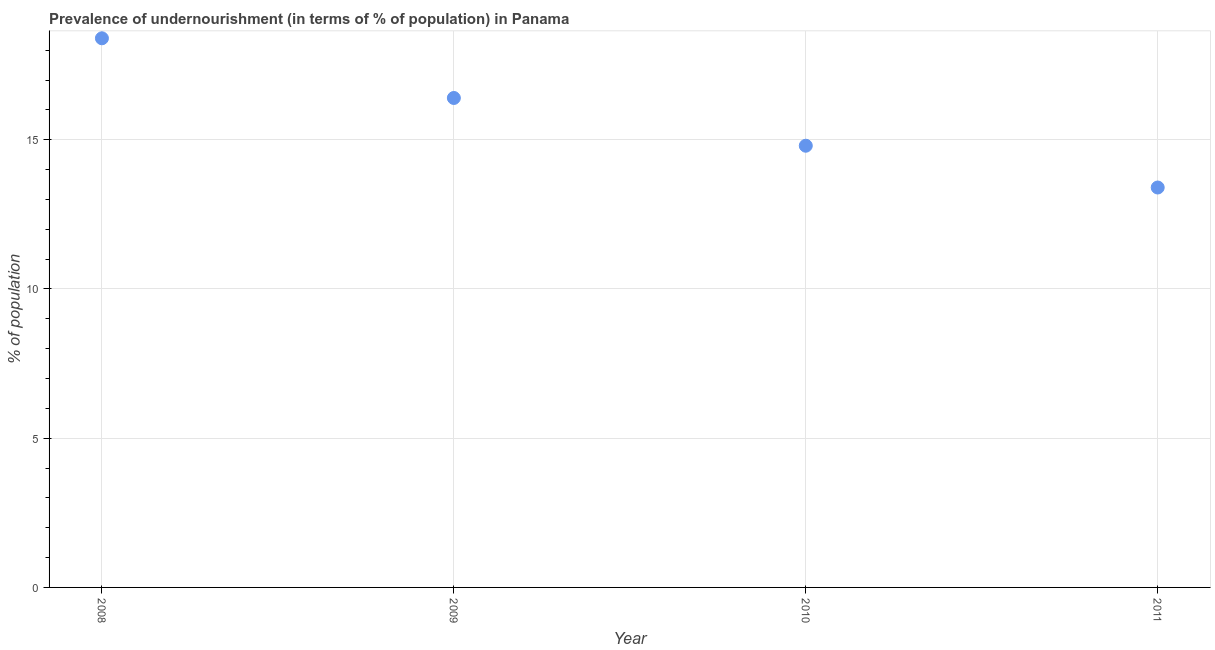What is the percentage of undernourished population in 2008?
Give a very brief answer. 18.4. Across all years, what is the minimum percentage of undernourished population?
Offer a terse response. 13.4. In which year was the percentage of undernourished population maximum?
Your answer should be compact. 2008. What is the sum of the percentage of undernourished population?
Make the answer very short. 63. What is the difference between the percentage of undernourished population in 2008 and 2011?
Your response must be concise. 5. What is the average percentage of undernourished population per year?
Provide a short and direct response. 15.75. What is the ratio of the percentage of undernourished population in 2009 to that in 2010?
Keep it short and to the point. 1.11. Is the percentage of undernourished population in 2008 less than that in 2011?
Make the answer very short. No. Is the difference between the percentage of undernourished population in 2009 and 2010 greater than the difference between any two years?
Offer a very short reply. No. What is the difference between the highest and the second highest percentage of undernourished population?
Your answer should be compact. 2. Is the sum of the percentage of undernourished population in 2010 and 2011 greater than the maximum percentage of undernourished population across all years?
Provide a short and direct response. Yes. What is the difference between the highest and the lowest percentage of undernourished population?
Keep it short and to the point. 5. Does the graph contain any zero values?
Your response must be concise. No. Does the graph contain grids?
Provide a short and direct response. Yes. What is the title of the graph?
Offer a very short reply. Prevalence of undernourishment (in terms of % of population) in Panama. What is the label or title of the Y-axis?
Give a very brief answer. % of population. What is the % of population in 2008?
Make the answer very short. 18.4. What is the % of population in 2009?
Your answer should be compact. 16.4. What is the % of population in 2011?
Provide a succinct answer. 13.4. What is the difference between the % of population in 2008 and 2009?
Give a very brief answer. 2. What is the difference between the % of population in 2008 and 2011?
Offer a very short reply. 5. What is the difference between the % of population in 2009 and 2010?
Your response must be concise. 1.6. What is the difference between the % of population in 2010 and 2011?
Offer a terse response. 1.4. What is the ratio of the % of population in 2008 to that in 2009?
Give a very brief answer. 1.12. What is the ratio of the % of population in 2008 to that in 2010?
Ensure brevity in your answer.  1.24. What is the ratio of the % of population in 2008 to that in 2011?
Offer a very short reply. 1.37. What is the ratio of the % of population in 2009 to that in 2010?
Keep it short and to the point. 1.11. What is the ratio of the % of population in 2009 to that in 2011?
Your response must be concise. 1.22. What is the ratio of the % of population in 2010 to that in 2011?
Your answer should be very brief. 1.1. 